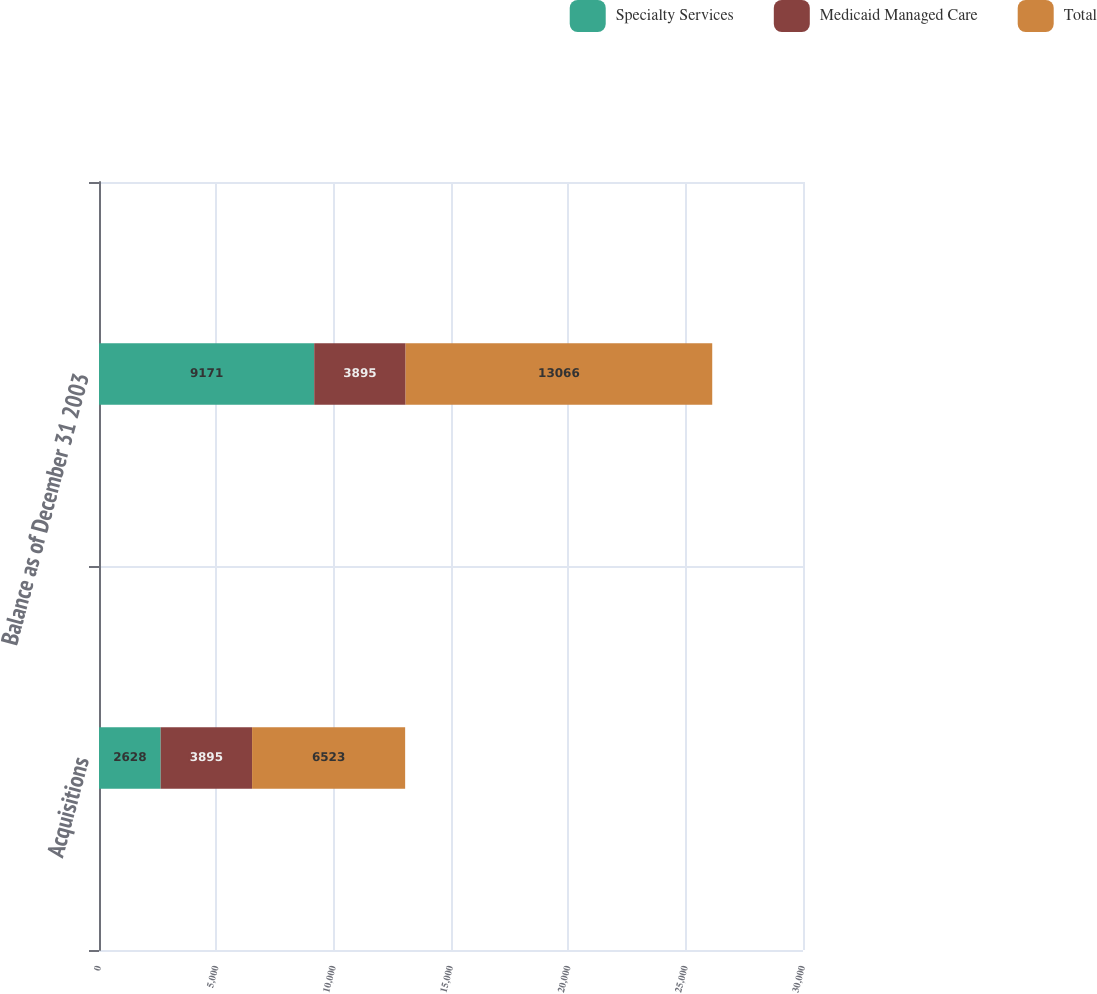<chart> <loc_0><loc_0><loc_500><loc_500><stacked_bar_chart><ecel><fcel>Acquisitions<fcel>Balance as of December 31 2003<nl><fcel>Specialty Services<fcel>2628<fcel>9171<nl><fcel>Medicaid Managed Care<fcel>3895<fcel>3895<nl><fcel>Total<fcel>6523<fcel>13066<nl></chart> 